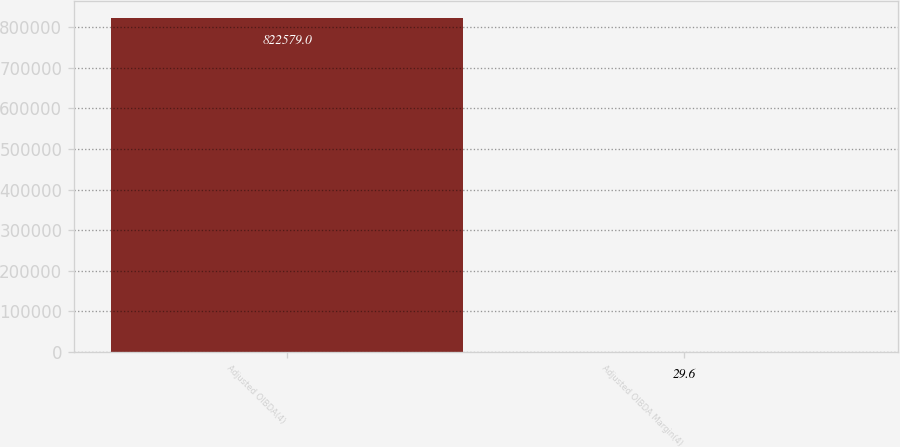Convert chart to OTSL. <chart><loc_0><loc_0><loc_500><loc_500><bar_chart><fcel>Adjusted OIBDA(4)<fcel>Adjusted OIBDA Margin(4)<nl><fcel>822579<fcel>29.6<nl></chart> 